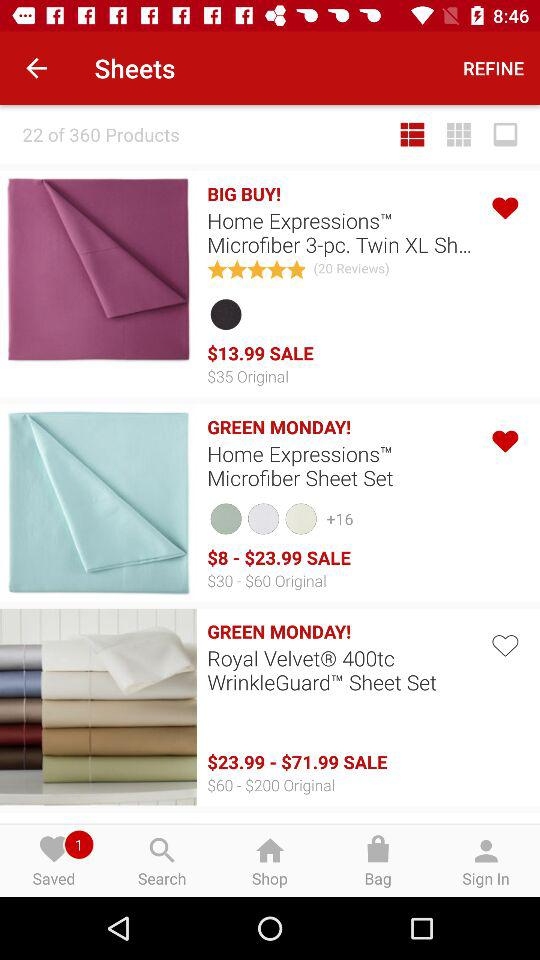For which item are +16 colors available? +16 colors are available for the "Home Expressions Microfiber Sheet Set". 